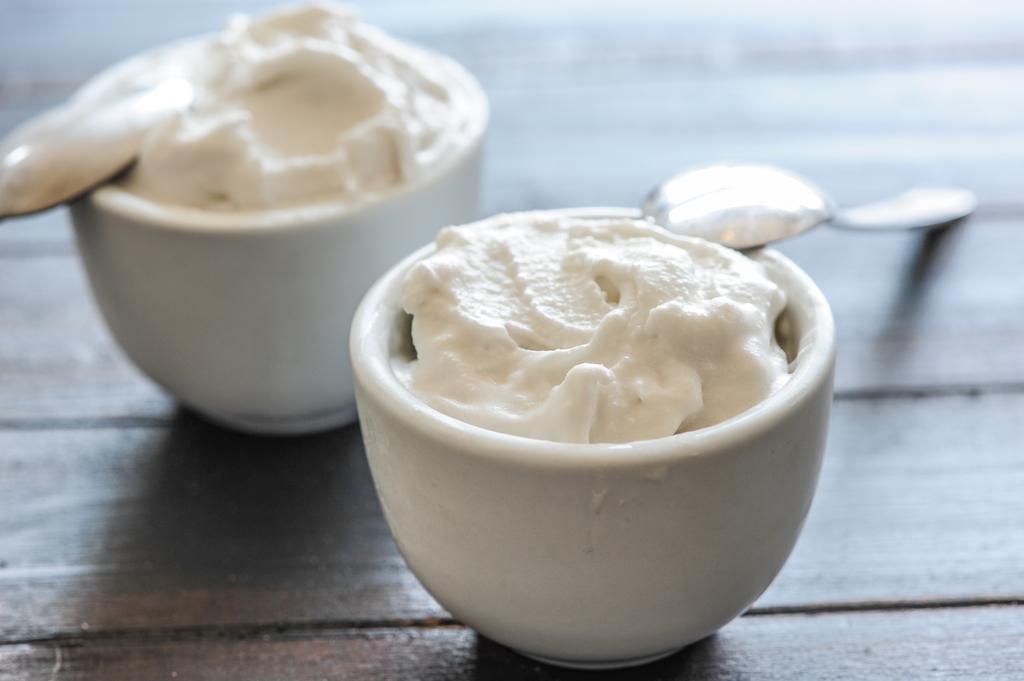How would you summarize this image in a sentence or two? In this picture there is a wooden table, on the table there are bowls, spoons and food item. At the top it is blurred. 